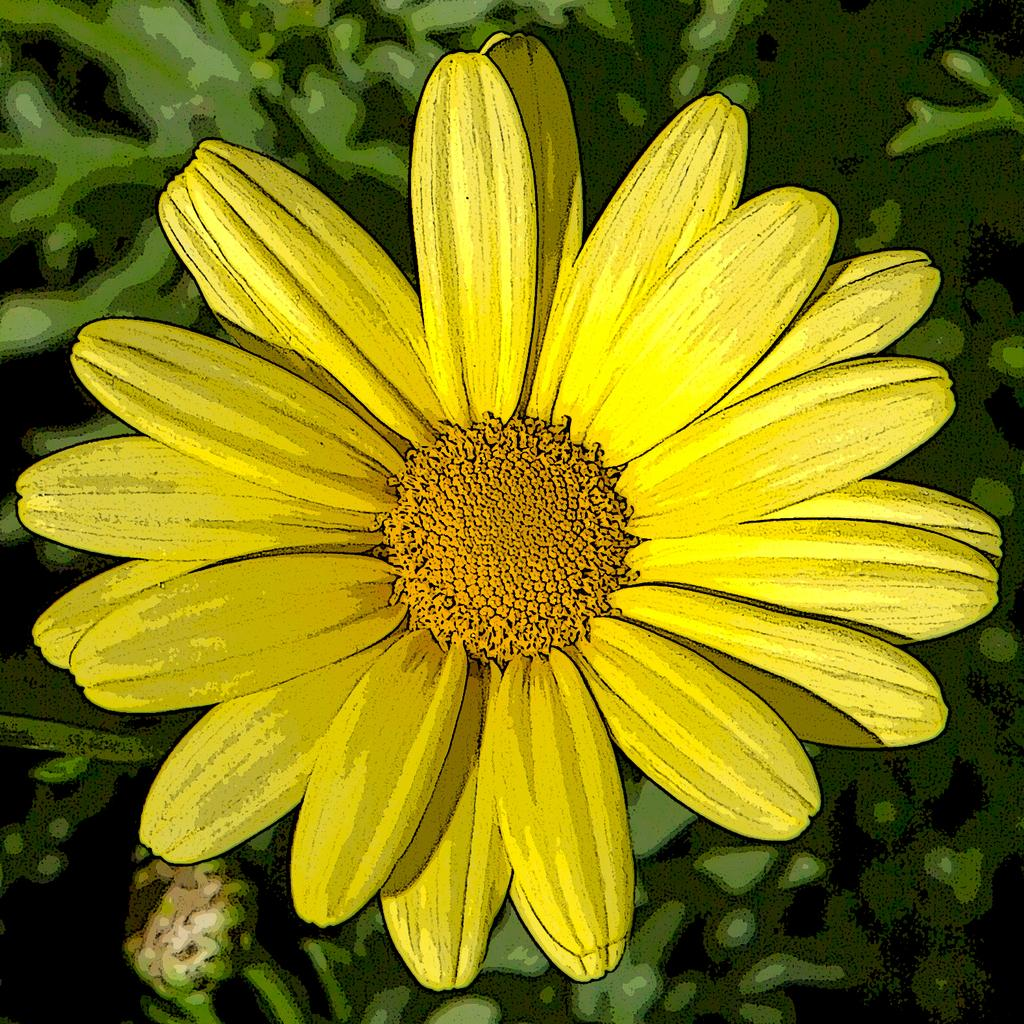What type of flower can be seen in the image? There is a yellow flower in the image. What else is present in the image besides the yellow flower? There are plants in the image. Can you describe the medium of the image? The image appears to be a painting. What type of quince is being cooked on the stove in the image? There is no quince or stove present in the image; it features a yellow flower and other plants. Can you describe the robin's nest in the image? There is no robin or nest present in the image; it is a painting of a yellow flower and plants. 